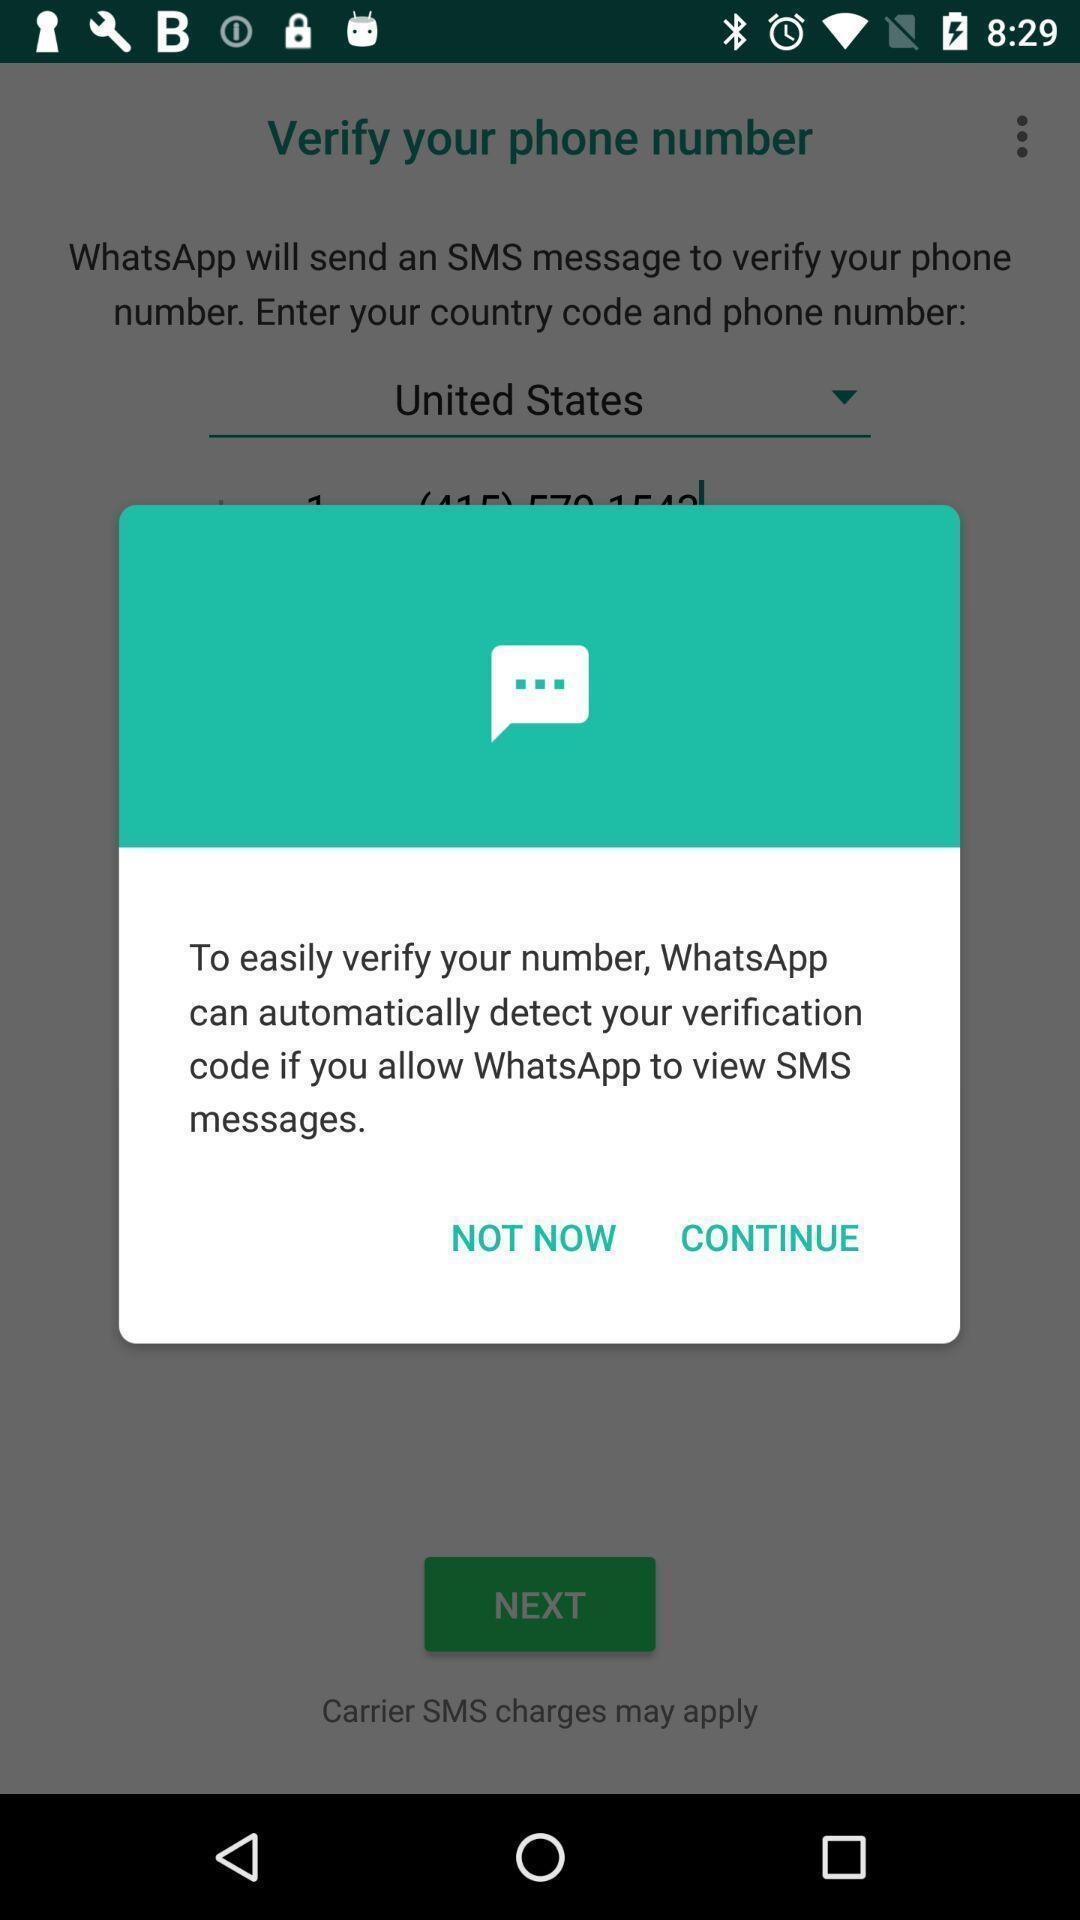Provide a textual representation of this image. Pop-up message from an app asking permission. 